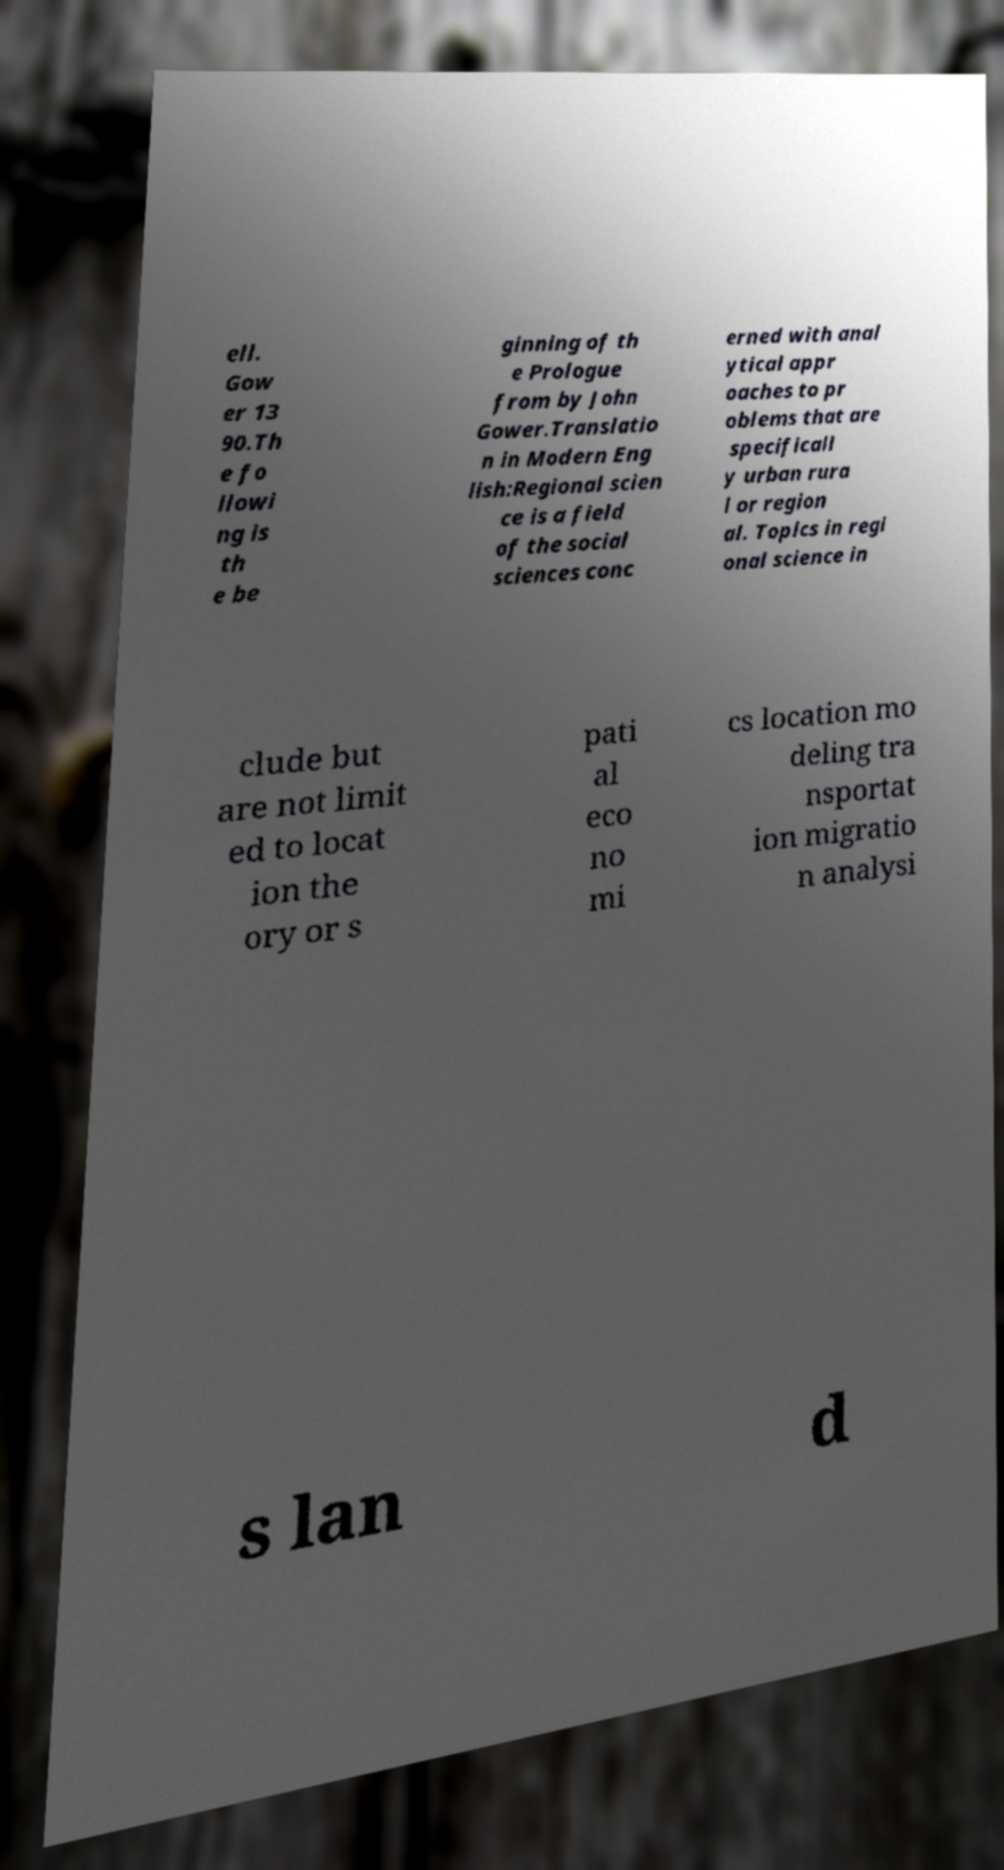Please identify and transcribe the text found in this image. ell. Gow er 13 90.Th e fo llowi ng is th e be ginning of th e Prologue from by John Gower.Translatio n in Modern Eng lish:Regional scien ce is a field of the social sciences conc erned with anal ytical appr oaches to pr oblems that are specificall y urban rura l or region al. Topics in regi onal science in clude but are not limit ed to locat ion the ory or s pati al eco no mi cs location mo deling tra nsportat ion migratio n analysi s lan d 